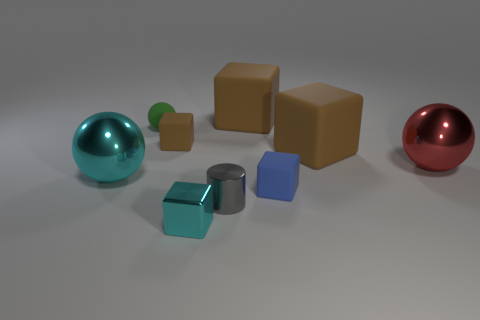How many cyan metal blocks have the same size as the blue rubber object? Upon reviewing the image, I can confirm that there is one cyan metal block that has the same size as the blue rubber object. It's intriguing to see how objects of different materials and colors can share identical dimensions, highlighting the diversity in a seemingly simple collection of shapes. 